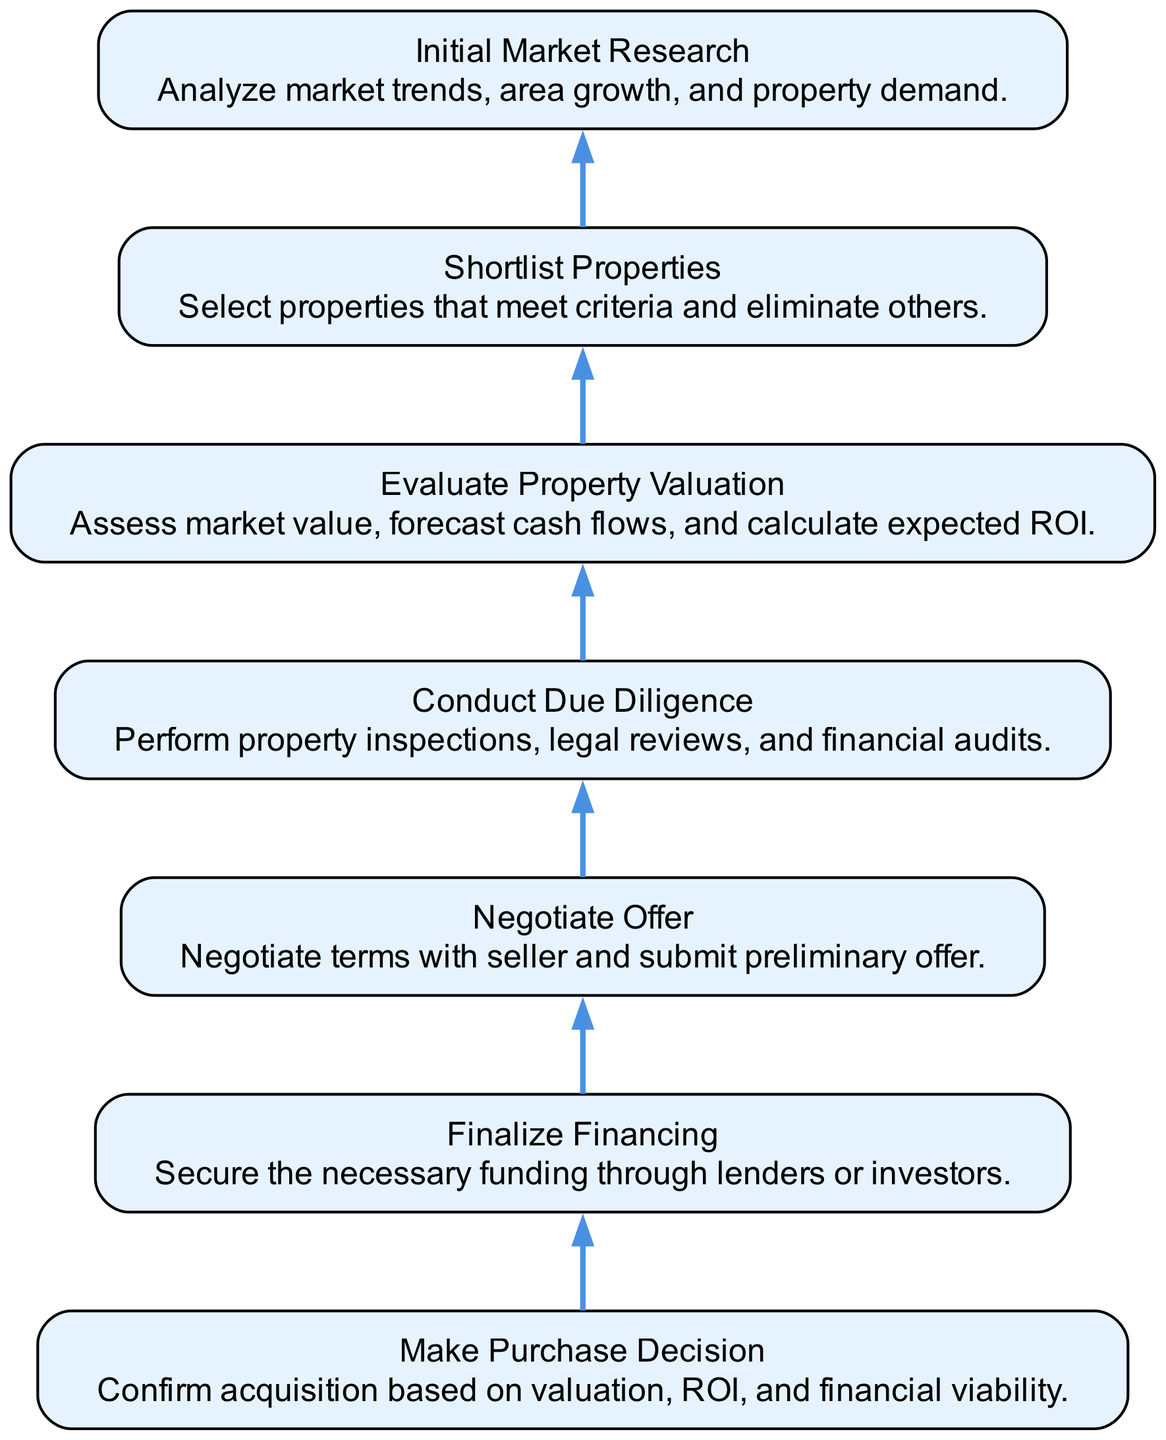What is the final step in the property acquisition process? The final step in the flowchart is "Make Purchase Decision," which involves confirming the acquisition based on valuation, ROI, and financial viability, as indicated by its position at the top of the diagram.
Answer: Make Purchase Decision How many total steps are there in the property acquisition process? The diagram contains a total of seven steps, as reflected by the seven elements listed in the flowchart, ranging from "Initial Market Research" at the bottom to "Make Purchase Decision" at the top.
Answer: Seven Which step involves securing funding? The step that involves securing funding is "Finalize Financing," which is the second step in the flowchart, directly below "Make Purchase Decision" and above "Negotiate Offer."
Answer: Finalize Financing What precedes the "Conduct Due Diligence" step? The step that precedes "Conduct Due Diligence" is "Negotiate Offer," which occurs directly below it in the flow from bottom to top as indicated by their sequential arrangement in the flowchart.
Answer: Negotiate Offer What is the purpose of the "Shortlist Properties" step? The purpose of the "Shortlist Properties" step is to select properties that meet established criteria and eliminate those that do not, as described in its position within the flowchart.
Answer: Select properties Which step involves analyzing market trends? The step that involves analyzing market trends is "Initial Market Research," which is the first step in the process located at the bottom of the diagram and serves as the foundation for all subsequent actions.
Answer: Initial Market Research How is the "Evaluate Property Valuation" step related to the "Shortlist Properties" step? "Evaluate Property Valuation" follows "Shortlist Properties," indicating that it occurs after a selection of potential properties has been made, allowing for a focused assessment of their market value and expected returns.
Answer: Follows What step comes immediately after "Evaluate Property Valuation"? The step that comes immediately after "Evaluate Property Valuation" is "Conduct Due Diligence," as demonstrated by the direct flow from evaluating the property through to performing inspections and audits.
Answer: Conduct Due Diligence 